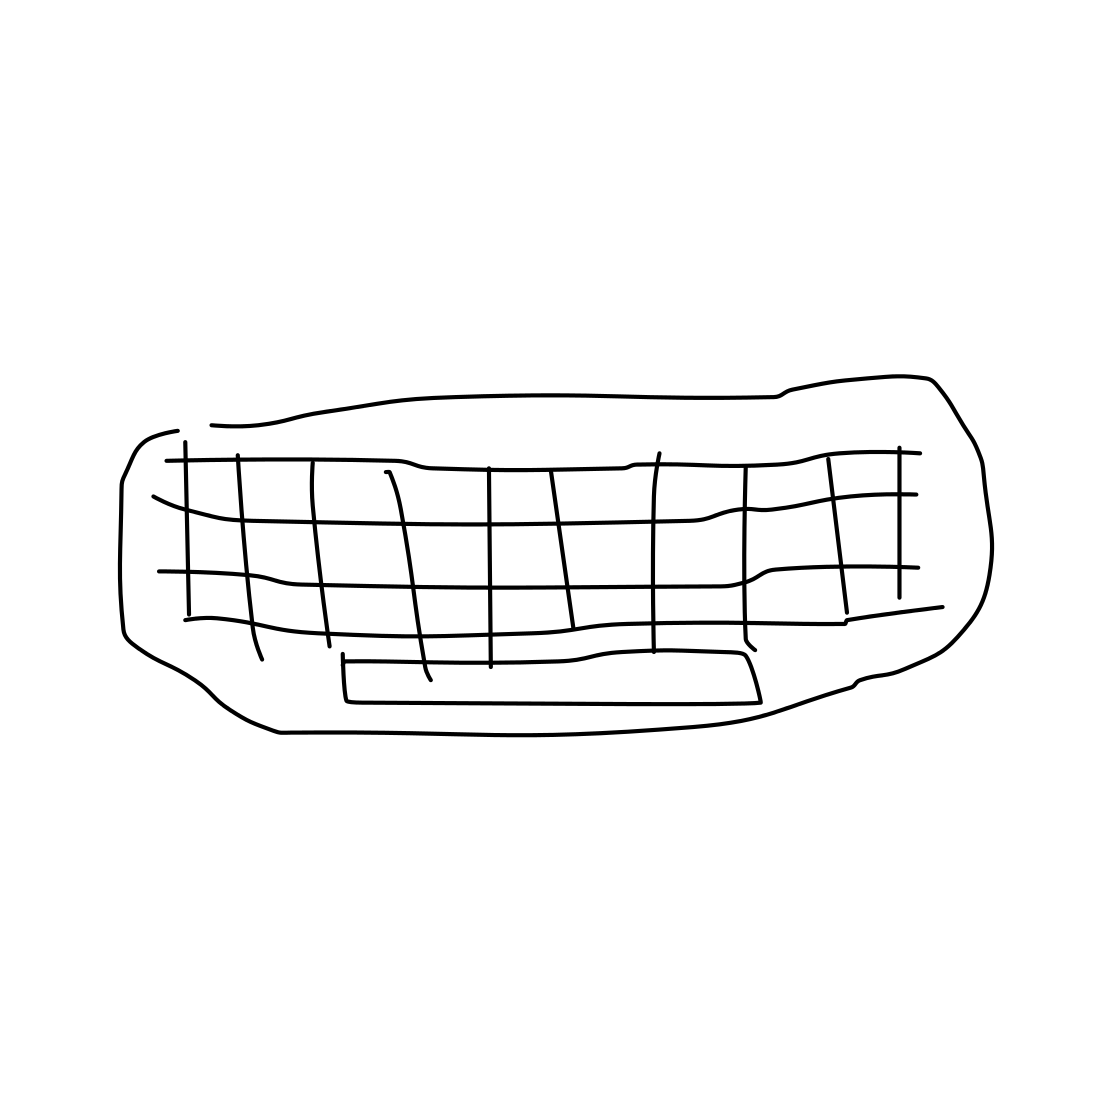Is this a drawing that would be used in a professional setting, perhaps in design or architecture? While the drawing is very simple, it could be the type of sketch used in the early stages of design work, to brainstorm layouts or furniture placement in interior design or architectural plans, before moving on to more detailed renderings. 